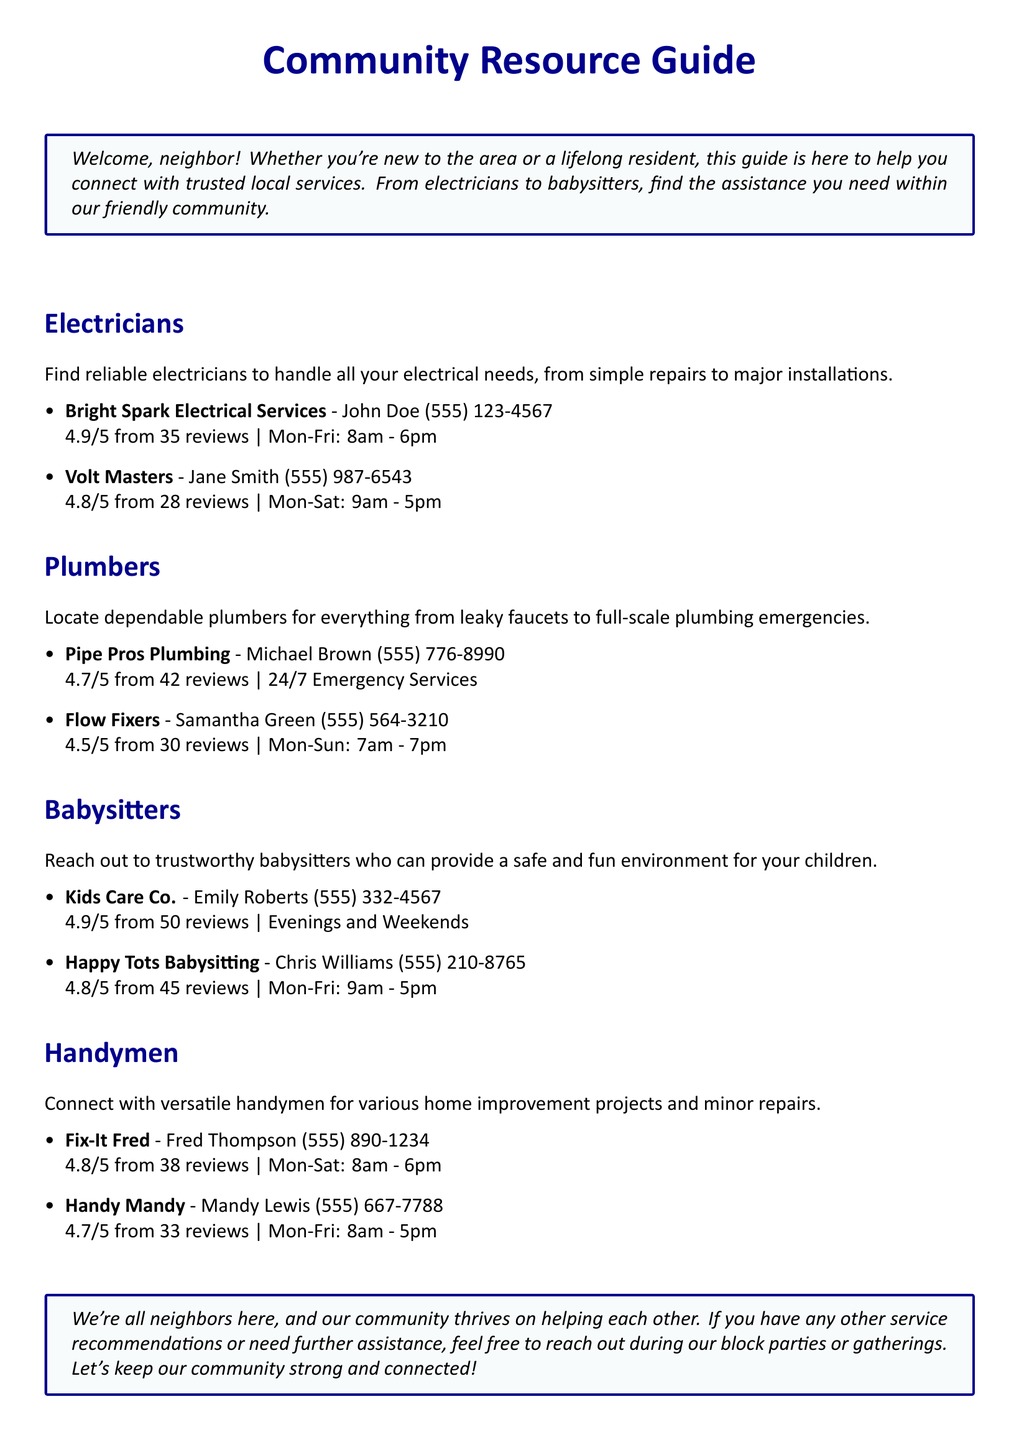What is the highest review rating among electricians? The highest review rating among electricians is found by comparing the ratings listed for both services. Bright Spark Electrical Services has a rating of 4.9/5.
Answer: 4.9/5 Who provides 24/7 emergency plumbing services? The document specifies that Pipe Pros Plumbing offers 24/7 Emergency Services, making them the provider for such services.
Answer: Pipe Pros Plumbing What is the contact number for Kids Care Co.? The document lists the contact number for Kids Care Co. as 555-332-4567.
Answer: 555-332-4567 How many reviews does Flow Fixers have? The number of reviews given for Flow Fixers is stated in the document; it shows 30 reviews.
Answer: 30 Which handyman has the lowest rating? To find the handyman with the lowest rating, you compare the ratings: Fix-It Fred (4.8/5) and Handy Mandy (4.7/5). Handy Mandy has the lowest rating.
Answer: Handy Mandy What days is Happy Tots Babysitting available? According to the document, Happy Tots Babysitting operates Monday through Friday, from 9am to 5pm.
Answer: Mon-Fri Who is the contact person for Volt Masters? The contact person associated with Volt Masters is Jane Smith as stated in the document.
Answer: Jane Smith What type of services does Fix-It Fred provide? The document indicates that Fix-It Fred is a handyman, providing various home improvement projects and minor repairs.
Answer: Handyman What is the availability of Kids Care Co.? Kids Care Co. is available during Evenings and Weekends, as described in the document.
Answer: Evenings and Weekends 